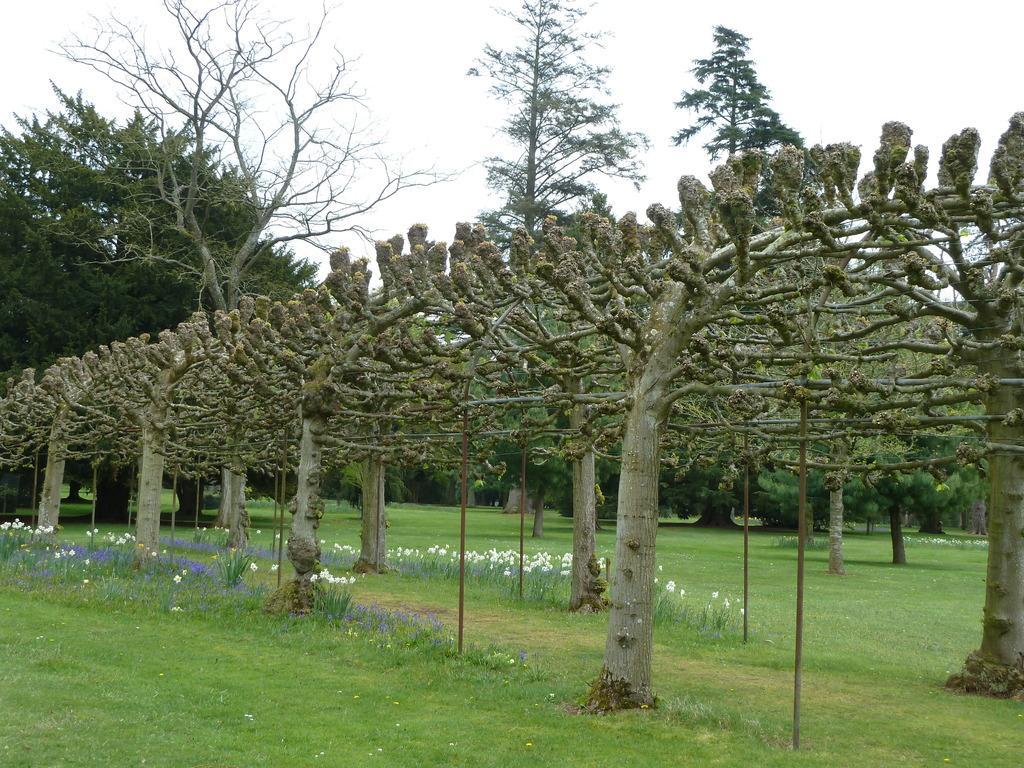Describe this image in one or two sentences. In the image there are different types of plants in a garden and beside the trees there are small flowers to the bushes. 